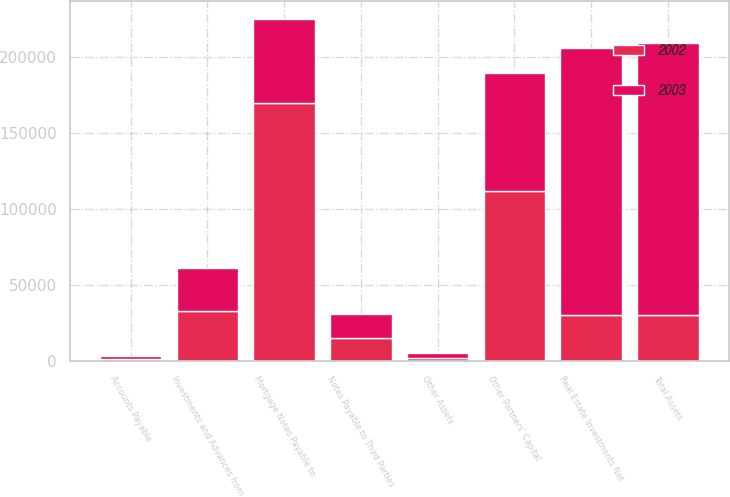<chart> <loc_0><loc_0><loc_500><loc_500><stacked_bar_chart><ecel><fcel>Real Estate Investments Net<fcel>Other Assets<fcel>Total Assets<fcel>Notes Payable to Third Parties<fcel>Mortgage Notes Payable to<fcel>Accounts Payable<fcel>Other Partners' Capital<fcel>Investments and Advances from<nl><fcel>2003<fcel>175796<fcel>3002<fcel>178798<fcel>15636<fcel>55532<fcel>1846<fcel>77490<fcel>28294<nl><fcel>2002<fcel>30479<fcel>2206<fcel>30479<fcel>15017<fcel>169787<fcel>1303<fcel>112094<fcel>32664<nl></chart> 